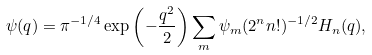<formula> <loc_0><loc_0><loc_500><loc_500>\psi ( q ) = \pi ^ { - 1 / 4 } \exp \left ( - \frac { q ^ { 2 } } { 2 } \right ) \sum _ { m } \psi _ { m } ( 2 ^ { n } n ! ) ^ { - 1 / 2 } H _ { n } ( q ) ,</formula> 